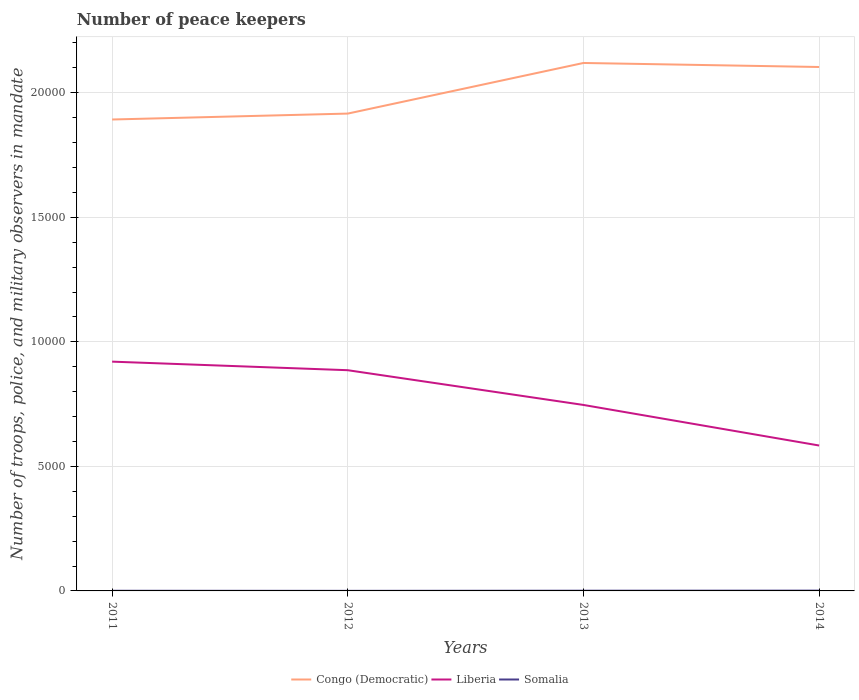How many different coloured lines are there?
Your response must be concise. 3. Does the line corresponding to Congo (Democratic) intersect with the line corresponding to Liberia?
Offer a very short reply. No. In which year was the number of peace keepers in in Somalia maximum?
Give a very brief answer. 2012. What is the total number of peace keepers in in Somalia in the graph?
Your answer should be very brief. -6. What is the difference between the highest and the second highest number of peace keepers in in Liberia?
Give a very brief answer. 3368. What is the difference between the highest and the lowest number of peace keepers in in Liberia?
Provide a succinct answer. 2. What is the difference between two consecutive major ticks on the Y-axis?
Offer a very short reply. 5000. Are the values on the major ticks of Y-axis written in scientific E-notation?
Give a very brief answer. No. Where does the legend appear in the graph?
Offer a very short reply. Bottom center. How are the legend labels stacked?
Your response must be concise. Horizontal. What is the title of the graph?
Offer a very short reply. Number of peace keepers. Does "East Asia (all income levels)" appear as one of the legend labels in the graph?
Your answer should be compact. No. What is the label or title of the Y-axis?
Offer a very short reply. Number of troops, police, and military observers in mandate. What is the Number of troops, police, and military observers in mandate of Congo (Democratic) in 2011?
Your answer should be very brief. 1.89e+04. What is the Number of troops, police, and military observers in mandate of Liberia in 2011?
Keep it short and to the point. 9206. What is the Number of troops, police, and military observers in mandate in Somalia in 2011?
Your answer should be very brief. 6. What is the Number of troops, police, and military observers in mandate of Congo (Democratic) in 2012?
Keep it short and to the point. 1.92e+04. What is the Number of troops, police, and military observers in mandate in Liberia in 2012?
Your response must be concise. 8862. What is the Number of troops, police, and military observers in mandate in Congo (Democratic) in 2013?
Offer a terse response. 2.12e+04. What is the Number of troops, police, and military observers in mandate in Liberia in 2013?
Offer a terse response. 7467. What is the Number of troops, police, and military observers in mandate in Congo (Democratic) in 2014?
Keep it short and to the point. 2.10e+04. What is the Number of troops, police, and military observers in mandate in Liberia in 2014?
Your answer should be compact. 5838. What is the Number of troops, police, and military observers in mandate of Somalia in 2014?
Offer a very short reply. 12. Across all years, what is the maximum Number of troops, police, and military observers in mandate of Congo (Democratic)?
Offer a very short reply. 2.12e+04. Across all years, what is the maximum Number of troops, police, and military observers in mandate of Liberia?
Your response must be concise. 9206. Across all years, what is the maximum Number of troops, police, and military observers in mandate in Somalia?
Offer a terse response. 12. Across all years, what is the minimum Number of troops, police, and military observers in mandate in Congo (Democratic)?
Give a very brief answer. 1.89e+04. Across all years, what is the minimum Number of troops, police, and military observers in mandate of Liberia?
Your answer should be compact. 5838. What is the total Number of troops, police, and military observers in mandate in Congo (Democratic) in the graph?
Provide a succinct answer. 8.03e+04. What is the total Number of troops, police, and military observers in mandate of Liberia in the graph?
Offer a terse response. 3.14e+04. What is the total Number of troops, police, and military observers in mandate of Somalia in the graph?
Provide a succinct answer. 30. What is the difference between the Number of troops, police, and military observers in mandate of Congo (Democratic) in 2011 and that in 2012?
Provide a succinct answer. -238. What is the difference between the Number of troops, police, and military observers in mandate of Liberia in 2011 and that in 2012?
Make the answer very short. 344. What is the difference between the Number of troops, police, and military observers in mandate of Somalia in 2011 and that in 2012?
Keep it short and to the point. 3. What is the difference between the Number of troops, police, and military observers in mandate in Congo (Democratic) in 2011 and that in 2013?
Ensure brevity in your answer.  -2270. What is the difference between the Number of troops, police, and military observers in mandate of Liberia in 2011 and that in 2013?
Give a very brief answer. 1739. What is the difference between the Number of troops, police, and military observers in mandate in Somalia in 2011 and that in 2013?
Provide a short and direct response. -3. What is the difference between the Number of troops, police, and military observers in mandate in Congo (Democratic) in 2011 and that in 2014?
Keep it short and to the point. -2108. What is the difference between the Number of troops, police, and military observers in mandate in Liberia in 2011 and that in 2014?
Provide a short and direct response. 3368. What is the difference between the Number of troops, police, and military observers in mandate in Somalia in 2011 and that in 2014?
Your response must be concise. -6. What is the difference between the Number of troops, police, and military observers in mandate of Congo (Democratic) in 2012 and that in 2013?
Keep it short and to the point. -2032. What is the difference between the Number of troops, police, and military observers in mandate of Liberia in 2012 and that in 2013?
Keep it short and to the point. 1395. What is the difference between the Number of troops, police, and military observers in mandate of Somalia in 2012 and that in 2013?
Ensure brevity in your answer.  -6. What is the difference between the Number of troops, police, and military observers in mandate in Congo (Democratic) in 2012 and that in 2014?
Your answer should be compact. -1870. What is the difference between the Number of troops, police, and military observers in mandate in Liberia in 2012 and that in 2014?
Offer a terse response. 3024. What is the difference between the Number of troops, police, and military observers in mandate of Somalia in 2012 and that in 2014?
Make the answer very short. -9. What is the difference between the Number of troops, police, and military observers in mandate in Congo (Democratic) in 2013 and that in 2014?
Give a very brief answer. 162. What is the difference between the Number of troops, police, and military observers in mandate in Liberia in 2013 and that in 2014?
Give a very brief answer. 1629. What is the difference between the Number of troops, police, and military observers in mandate of Somalia in 2013 and that in 2014?
Keep it short and to the point. -3. What is the difference between the Number of troops, police, and military observers in mandate in Congo (Democratic) in 2011 and the Number of troops, police, and military observers in mandate in Liberia in 2012?
Provide a short and direct response. 1.01e+04. What is the difference between the Number of troops, police, and military observers in mandate in Congo (Democratic) in 2011 and the Number of troops, police, and military observers in mandate in Somalia in 2012?
Provide a succinct answer. 1.89e+04. What is the difference between the Number of troops, police, and military observers in mandate in Liberia in 2011 and the Number of troops, police, and military observers in mandate in Somalia in 2012?
Keep it short and to the point. 9203. What is the difference between the Number of troops, police, and military observers in mandate in Congo (Democratic) in 2011 and the Number of troops, police, and military observers in mandate in Liberia in 2013?
Provide a succinct answer. 1.15e+04. What is the difference between the Number of troops, police, and military observers in mandate of Congo (Democratic) in 2011 and the Number of troops, police, and military observers in mandate of Somalia in 2013?
Offer a very short reply. 1.89e+04. What is the difference between the Number of troops, police, and military observers in mandate of Liberia in 2011 and the Number of troops, police, and military observers in mandate of Somalia in 2013?
Offer a very short reply. 9197. What is the difference between the Number of troops, police, and military observers in mandate of Congo (Democratic) in 2011 and the Number of troops, police, and military observers in mandate of Liberia in 2014?
Your answer should be very brief. 1.31e+04. What is the difference between the Number of troops, police, and military observers in mandate of Congo (Democratic) in 2011 and the Number of troops, police, and military observers in mandate of Somalia in 2014?
Keep it short and to the point. 1.89e+04. What is the difference between the Number of troops, police, and military observers in mandate of Liberia in 2011 and the Number of troops, police, and military observers in mandate of Somalia in 2014?
Your response must be concise. 9194. What is the difference between the Number of troops, police, and military observers in mandate in Congo (Democratic) in 2012 and the Number of troops, police, and military observers in mandate in Liberia in 2013?
Provide a succinct answer. 1.17e+04. What is the difference between the Number of troops, police, and military observers in mandate of Congo (Democratic) in 2012 and the Number of troops, police, and military observers in mandate of Somalia in 2013?
Provide a short and direct response. 1.92e+04. What is the difference between the Number of troops, police, and military observers in mandate of Liberia in 2012 and the Number of troops, police, and military observers in mandate of Somalia in 2013?
Ensure brevity in your answer.  8853. What is the difference between the Number of troops, police, and military observers in mandate of Congo (Democratic) in 2012 and the Number of troops, police, and military observers in mandate of Liberia in 2014?
Provide a short and direct response. 1.33e+04. What is the difference between the Number of troops, police, and military observers in mandate of Congo (Democratic) in 2012 and the Number of troops, police, and military observers in mandate of Somalia in 2014?
Offer a terse response. 1.92e+04. What is the difference between the Number of troops, police, and military observers in mandate of Liberia in 2012 and the Number of troops, police, and military observers in mandate of Somalia in 2014?
Provide a succinct answer. 8850. What is the difference between the Number of troops, police, and military observers in mandate in Congo (Democratic) in 2013 and the Number of troops, police, and military observers in mandate in Liberia in 2014?
Keep it short and to the point. 1.54e+04. What is the difference between the Number of troops, police, and military observers in mandate of Congo (Democratic) in 2013 and the Number of troops, police, and military observers in mandate of Somalia in 2014?
Offer a terse response. 2.12e+04. What is the difference between the Number of troops, police, and military observers in mandate of Liberia in 2013 and the Number of troops, police, and military observers in mandate of Somalia in 2014?
Make the answer very short. 7455. What is the average Number of troops, police, and military observers in mandate of Congo (Democratic) per year?
Offer a terse response. 2.01e+04. What is the average Number of troops, police, and military observers in mandate in Liberia per year?
Keep it short and to the point. 7843.25. What is the average Number of troops, police, and military observers in mandate in Somalia per year?
Make the answer very short. 7.5. In the year 2011, what is the difference between the Number of troops, police, and military observers in mandate in Congo (Democratic) and Number of troops, police, and military observers in mandate in Liberia?
Offer a very short reply. 9722. In the year 2011, what is the difference between the Number of troops, police, and military observers in mandate in Congo (Democratic) and Number of troops, police, and military observers in mandate in Somalia?
Your answer should be very brief. 1.89e+04. In the year 2011, what is the difference between the Number of troops, police, and military observers in mandate of Liberia and Number of troops, police, and military observers in mandate of Somalia?
Give a very brief answer. 9200. In the year 2012, what is the difference between the Number of troops, police, and military observers in mandate of Congo (Democratic) and Number of troops, police, and military observers in mandate of Liberia?
Make the answer very short. 1.03e+04. In the year 2012, what is the difference between the Number of troops, police, and military observers in mandate in Congo (Democratic) and Number of troops, police, and military observers in mandate in Somalia?
Your answer should be very brief. 1.92e+04. In the year 2012, what is the difference between the Number of troops, police, and military observers in mandate of Liberia and Number of troops, police, and military observers in mandate of Somalia?
Offer a terse response. 8859. In the year 2013, what is the difference between the Number of troops, police, and military observers in mandate of Congo (Democratic) and Number of troops, police, and military observers in mandate of Liberia?
Your response must be concise. 1.37e+04. In the year 2013, what is the difference between the Number of troops, police, and military observers in mandate of Congo (Democratic) and Number of troops, police, and military observers in mandate of Somalia?
Provide a short and direct response. 2.12e+04. In the year 2013, what is the difference between the Number of troops, police, and military observers in mandate in Liberia and Number of troops, police, and military observers in mandate in Somalia?
Offer a very short reply. 7458. In the year 2014, what is the difference between the Number of troops, police, and military observers in mandate of Congo (Democratic) and Number of troops, police, and military observers in mandate of Liberia?
Your answer should be very brief. 1.52e+04. In the year 2014, what is the difference between the Number of troops, police, and military observers in mandate of Congo (Democratic) and Number of troops, police, and military observers in mandate of Somalia?
Provide a short and direct response. 2.10e+04. In the year 2014, what is the difference between the Number of troops, police, and military observers in mandate in Liberia and Number of troops, police, and military observers in mandate in Somalia?
Provide a short and direct response. 5826. What is the ratio of the Number of troops, police, and military observers in mandate in Congo (Democratic) in 2011 to that in 2012?
Provide a succinct answer. 0.99. What is the ratio of the Number of troops, police, and military observers in mandate of Liberia in 2011 to that in 2012?
Give a very brief answer. 1.04. What is the ratio of the Number of troops, police, and military observers in mandate of Somalia in 2011 to that in 2012?
Make the answer very short. 2. What is the ratio of the Number of troops, police, and military observers in mandate of Congo (Democratic) in 2011 to that in 2013?
Provide a short and direct response. 0.89. What is the ratio of the Number of troops, police, and military observers in mandate of Liberia in 2011 to that in 2013?
Give a very brief answer. 1.23. What is the ratio of the Number of troops, police, and military observers in mandate in Somalia in 2011 to that in 2013?
Give a very brief answer. 0.67. What is the ratio of the Number of troops, police, and military observers in mandate in Congo (Democratic) in 2011 to that in 2014?
Provide a succinct answer. 0.9. What is the ratio of the Number of troops, police, and military observers in mandate of Liberia in 2011 to that in 2014?
Provide a short and direct response. 1.58. What is the ratio of the Number of troops, police, and military observers in mandate of Congo (Democratic) in 2012 to that in 2013?
Your answer should be compact. 0.9. What is the ratio of the Number of troops, police, and military observers in mandate of Liberia in 2012 to that in 2013?
Give a very brief answer. 1.19. What is the ratio of the Number of troops, police, and military observers in mandate in Somalia in 2012 to that in 2013?
Your response must be concise. 0.33. What is the ratio of the Number of troops, police, and military observers in mandate in Congo (Democratic) in 2012 to that in 2014?
Keep it short and to the point. 0.91. What is the ratio of the Number of troops, police, and military observers in mandate of Liberia in 2012 to that in 2014?
Make the answer very short. 1.52. What is the ratio of the Number of troops, police, and military observers in mandate in Congo (Democratic) in 2013 to that in 2014?
Provide a short and direct response. 1.01. What is the ratio of the Number of troops, police, and military observers in mandate of Liberia in 2013 to that in 2014?
Give a very brief answer. 1.28. What is the difference between the highest and the second highest Number of troops, police, and military observers in mandate of Congo (Democratic)?
Your response must be concise. 162. What is the difference between the highest and the second highest Number of troops, police, and military observers in mandate in Liberia?
Offer a terse response. 344. What is the difference between the highest and the lowest Number of troops, police, and military observers in mandate of Congo (Democratic)?
Give a very brief answer. 2270. What is the difference between the highest and the lowest Number of troops, police, and military observers in mandate in Liberia?
Make the answer very short. 3368. What is the difference between the highest and the lowest Number of troops, police, and military observers in mandate of Somalia?
Provide a succinct answer. 9. 